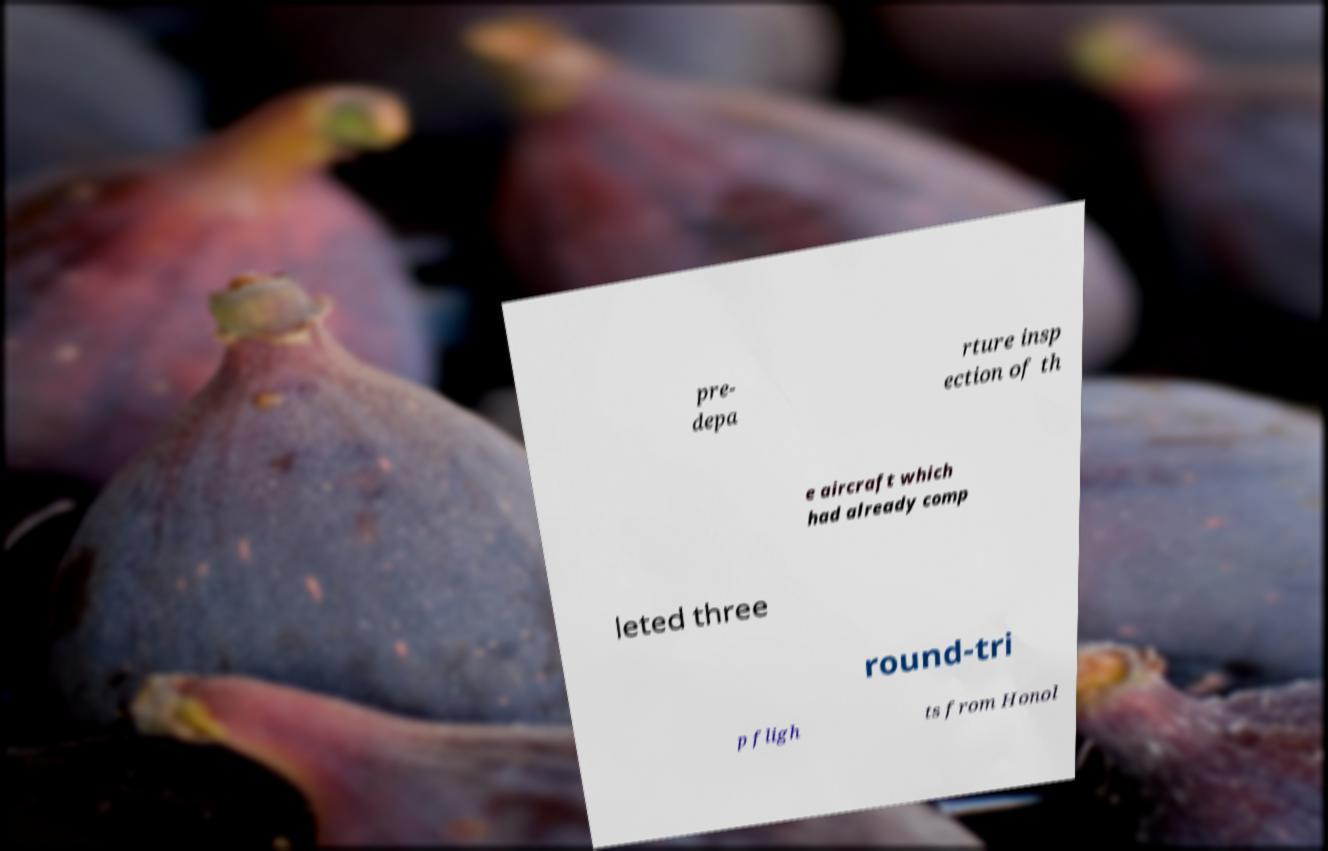Please identify and transcribe the text found in this image. pre- depa rture insp ection of th e aircraft which had already comp leted three round-tri p fligh ts from Honol 